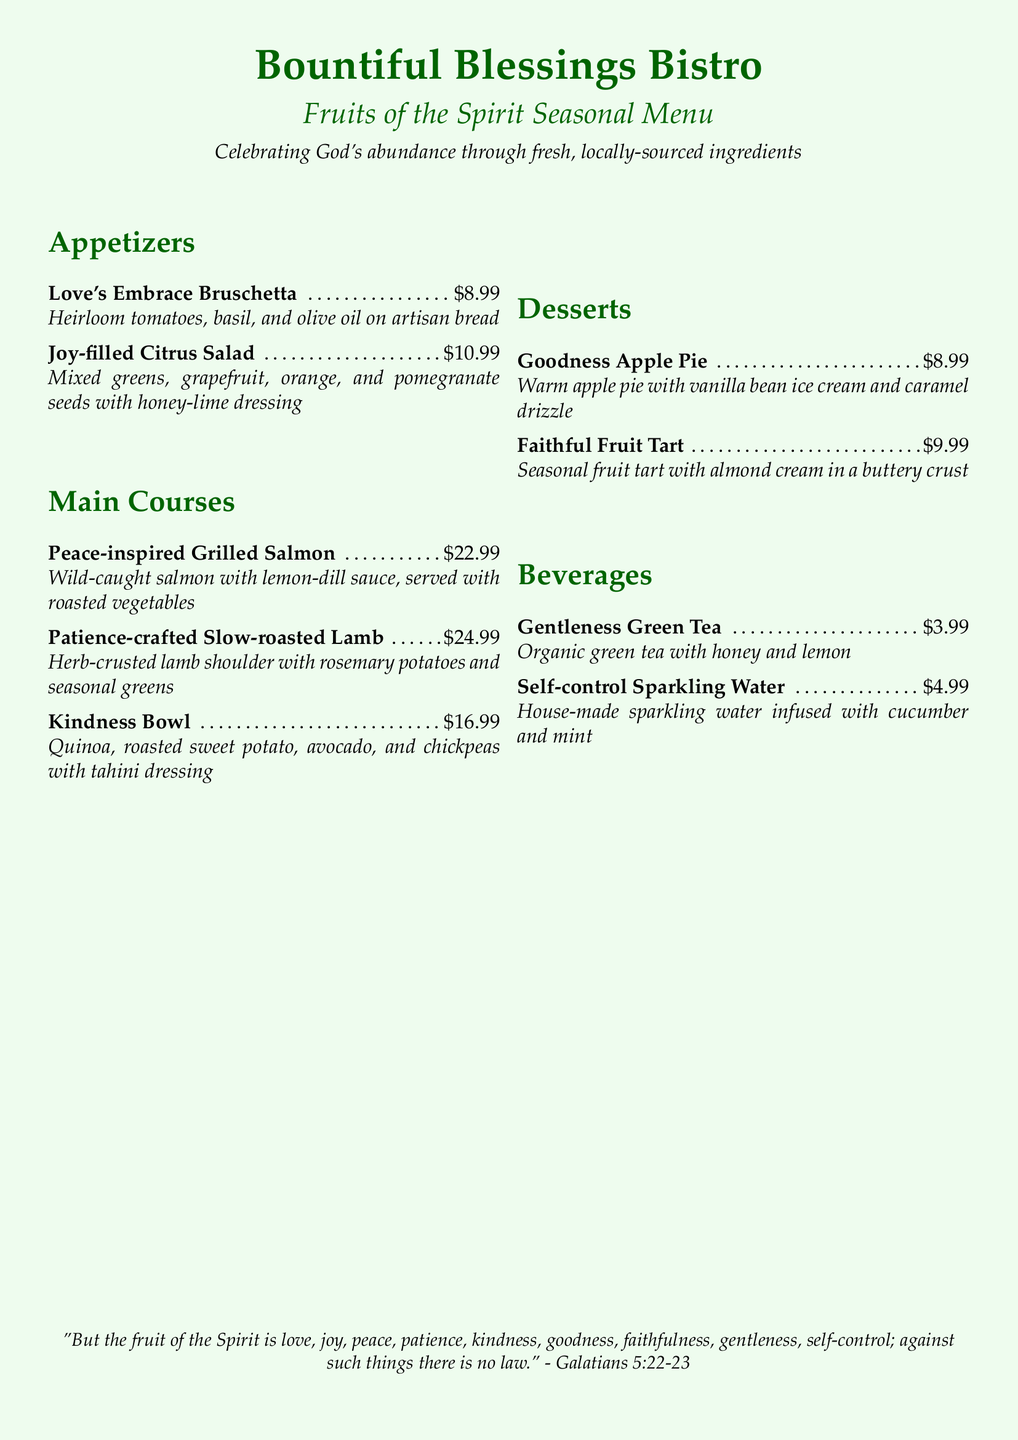What is the price of Love's Embrace Bruschetta? The price for Love's Embrace Bruschetta is listed directly in the menu under appetizers.
Answer: $8.99 What are the ingredients in Joy-filled Citrus Salad? The ingredients can be found in the menu description for Joy-filled Citrus Salad.
Answer: Mixed greens, grapefruit, orange, and pomegranate seeds with honey-lime dressing How much does the Peace-inspired Grilled Salmon cost? The cost of Peace-inspired Grilled Salmon is specified in the main courses section of the menu.
Answer: $22.99 Which dessert has vanilla bean ice cream? The menu lists desserts, and the one that includes vanilla bean ice cream can be found in the descriptions.
Answer: Goodness Apple Pie How many beverages are listed on the menu? The count of beverages can be determined by reviewing the beverage section of the menu.
Answer: 2 What is the main ingredient of the Kindness Bowl? The main ingredient of Kindness Bowl is highlighted in the description of the dish on the menu.
Answer: Quinoa Which course features a fruit tart? The specific course that includes a fruit tart can be identified in the desserts section of the menu.
Answer: Desserts What scripture is referenced at the bottom of the menu? The scripture is quoted directly at the end of the document and can be easily located.
Answer: Galatians 5:22-23 What color is the background of the menu? The background color is specified in the document's LaTeX commands related to page coloring.
Answer: Light green 